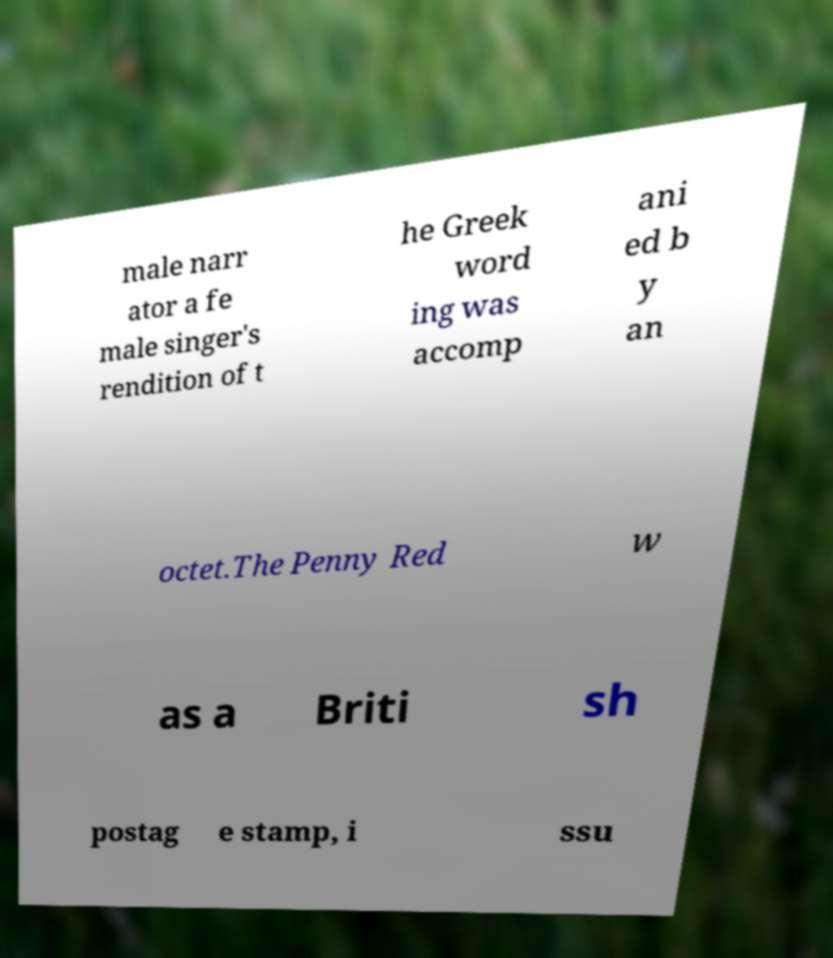I need the written content from this picture converted into text. Can you do that? male narr ator a fe male singer's rendition of t he Greek word ing was accomp ani ed b y an octet.The Penny Red w as a Briti sh postag e stamp, i ssu 